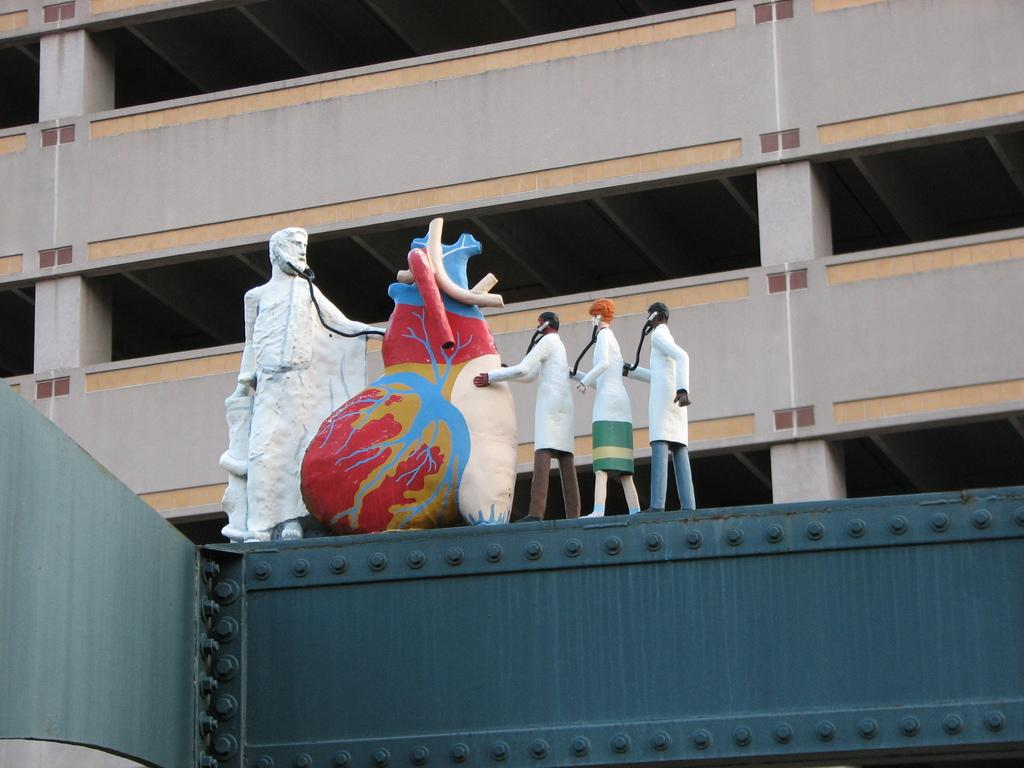What is present on the wall in the image? The wall has statues of persons and a heart in the image. Can you describe the statues on the wall? The statues on the wall are of persons. What is visible in the background of the image? There is a building in the background of the image. What type of apple is being used to decorate the heart on the wall? There is no apple present in the image; the heart on the wall does not have any apples. 